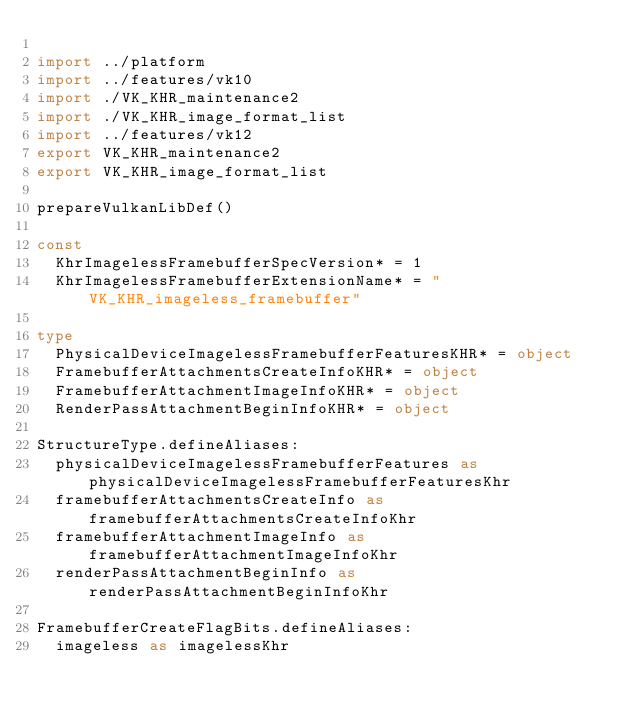<code> <loc_0><loc_0><loc_500><loc_500><_Nim_>
import ../platform
import ../features/vk10
import ./VK_KHR_maintenance2
import ./VK_KHR_image_format_list
import ../features/vk12
export VK_KHR_maintenance2
export VK_KHR_image_format_list

prepareVulkanLibDef()

const
  KhrImagelessFramebufferSpecVersion* = 1
  KhrImagelessFramebufferExtensionName* = "VK_KHR_imageless_framebuffer"

type
  PhysicalDeviceImagelessFramebufferFeaturesKHR* = object
  FramebufferAttachmentsCreateInfoKHR* = object
  FramebufferAttachmentImageInfoKHR* = object
  RenderPassAttachmentBeginInfoKHR* = object

StructureType.defineAliases:
  physicalDeviceImagelessFramebufferFeatures as physicalDeviceImagelessFramebufferFeaturesKhr
  framebufferAttachmentsCreateInfo as framebufferAttachmentsCreateInfoKhr
  framebufferAttachmentImageInfo as framebufferAttachmentImageInfoKhr
  renderPassAttachmentBeginInfo as renderPassAttachmentBeginInfoKhr

FramebufferCreateFlagBits.defineAliases:
  imageless as imagelessKhr


</code> 